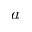<formula> <loc_0><loc_0><loc_500><loc_500>a</formula> 